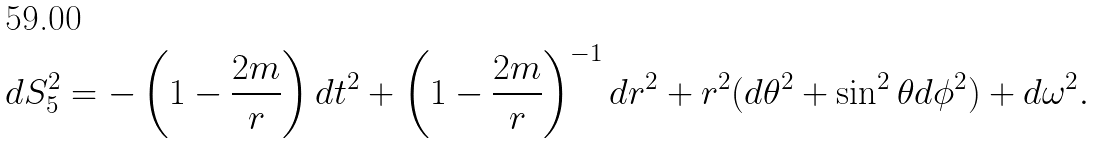Convert formula to latex. <formula><loc_0><loc_0><loc_500><loc_500>d S _ { 5 } ^ { 2 } = - \left ( 1 - \frac { 2 m } { r } \right ) d t ^ { 2 } + \left ( 1 - \frac { 2 m } { r } \right ) ^ { - 1 } d r ^ { 2 } + r ^ { 2 } ( d \theta ^ { 2 } + \sin ^ { 2 } \theta d \phi ^ { 2 } ) + d \omega ^ { 2 } .</formula> 